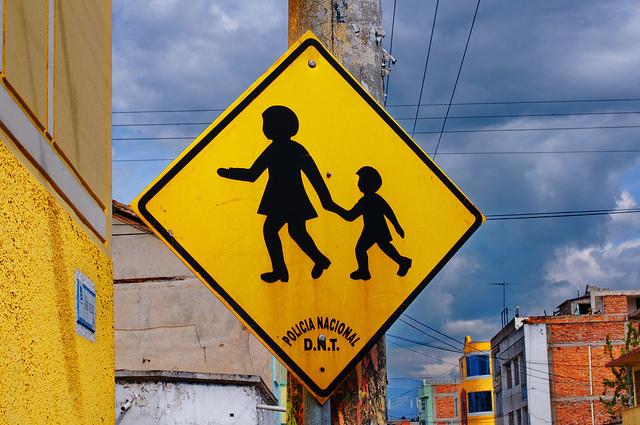What does the sign mean?
Short answer required. Children crossing. How many people are represented on the sign?
Keep it brief. 2. What is sign hanging on?
Concise answer only. Pole. 